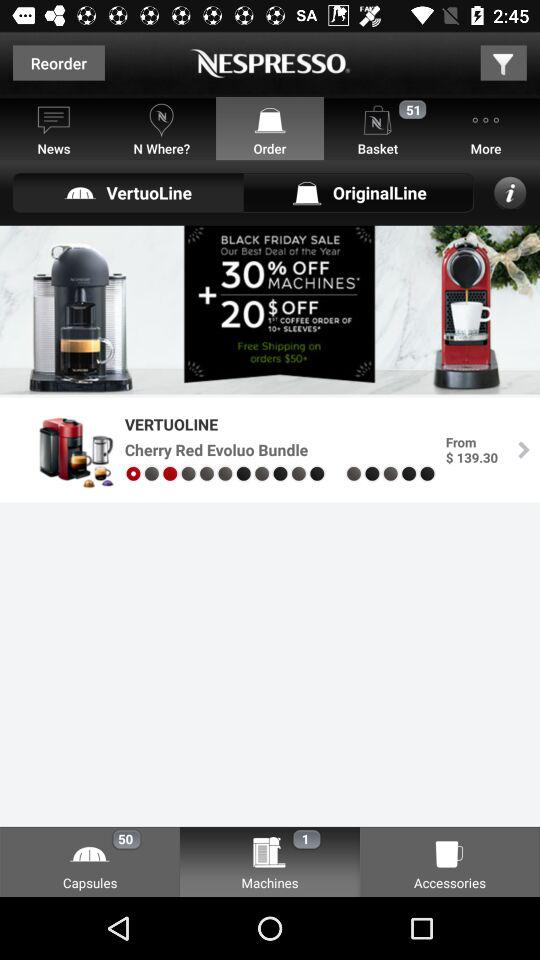How many different types of products are offered?
Answer the question using a single word or phrase. 3 